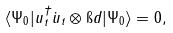Convert formula to latex. <formula><loc_0><loc_0><loc_500><loc_500>\langle \Psi _ { 0 } | u _ { t } ^ { \dagger } \dot { u } _ { t } \otimes \i d | \Psi _ { 0 } \rangle = 0 ,</formula> 